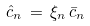Convert formula to latex. <formula><loc_0><loc_0><loc_500><loc_500>\hat { c } _ { n } \, = \, \xi _ { n } \, \bar { c } _ { n }</formula> 